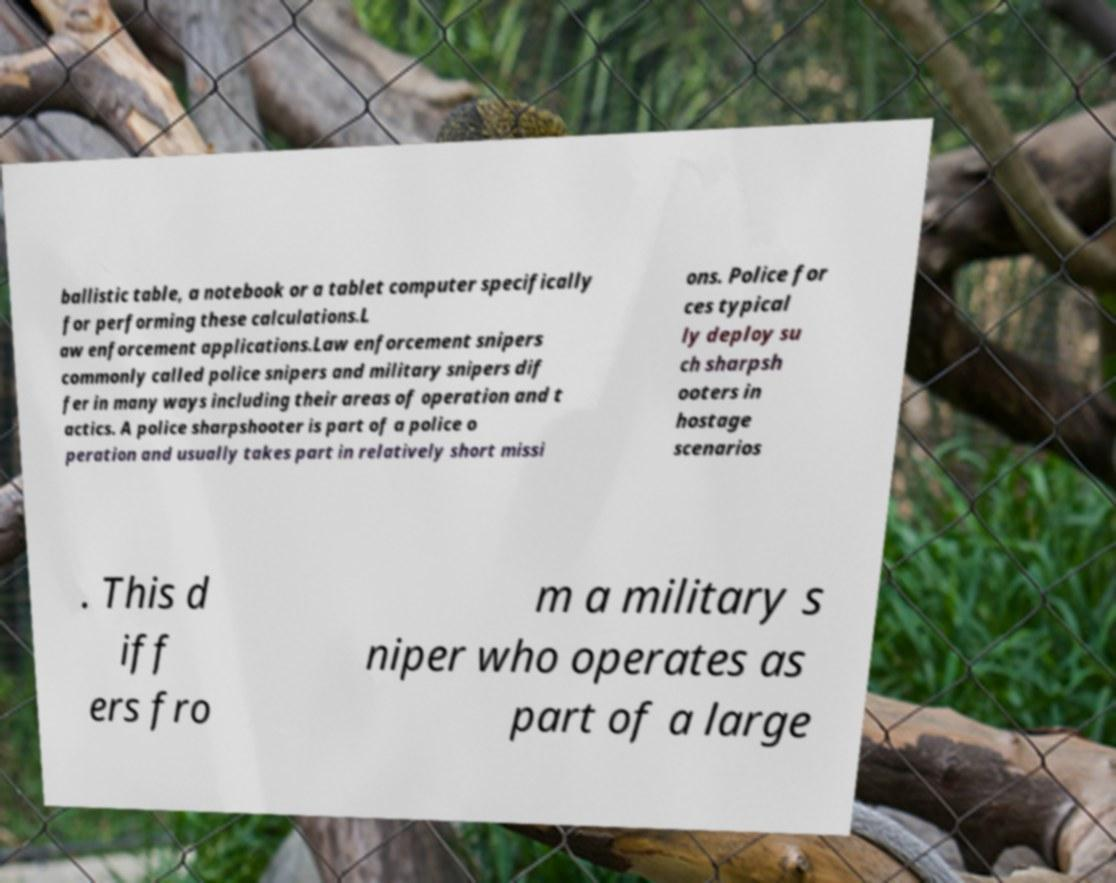Could you assist in decoding the text presented in this image and type it out clearly? ballistic table, a notebook or a tablet computer specifically for performing these calculations.L aw enforcement applications.Law enforcement snipers commonly called police snipers and military snipers dif fer in many ways including their areas of operation and t actics. A police sharpshooter is part of a police o peration and usually takes part in relatively short missi ons. Police for ces typical ly deploy su ch sharpsh ooters in hostage scenarios . This d iff ers fro m a military s niper who operates as part of a large 